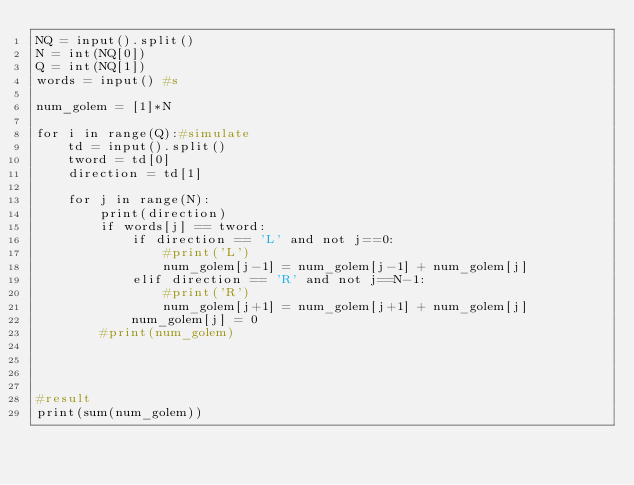<code> <loc_0><loc_0><loc_500><loc_500><_Python_>NQ = input().split()
N = int(NQ[0])
Q = int(NQ[1])
words = input() #s

num_golem = [1]*N

for i in range(Q):#simulate
    td = input().split()
    tword = td[0]
    direction = td[1]

    for j in range(N):
        print(direction)
        if words[j] == tword:
            if direction == 'L' and not j==0:
                #print('L')
                num_golem[j-1] = num_golem[j-1] + num_golem[j]
            elif direction == 'R' and not j==N-1:
                #print('R')
                num_golem[j+1] = num_golem[j+1] + num_golem[j]
            num_golem[j] = 0
        #print(num_golem)




#result
print(sum(num_golem))</code> 